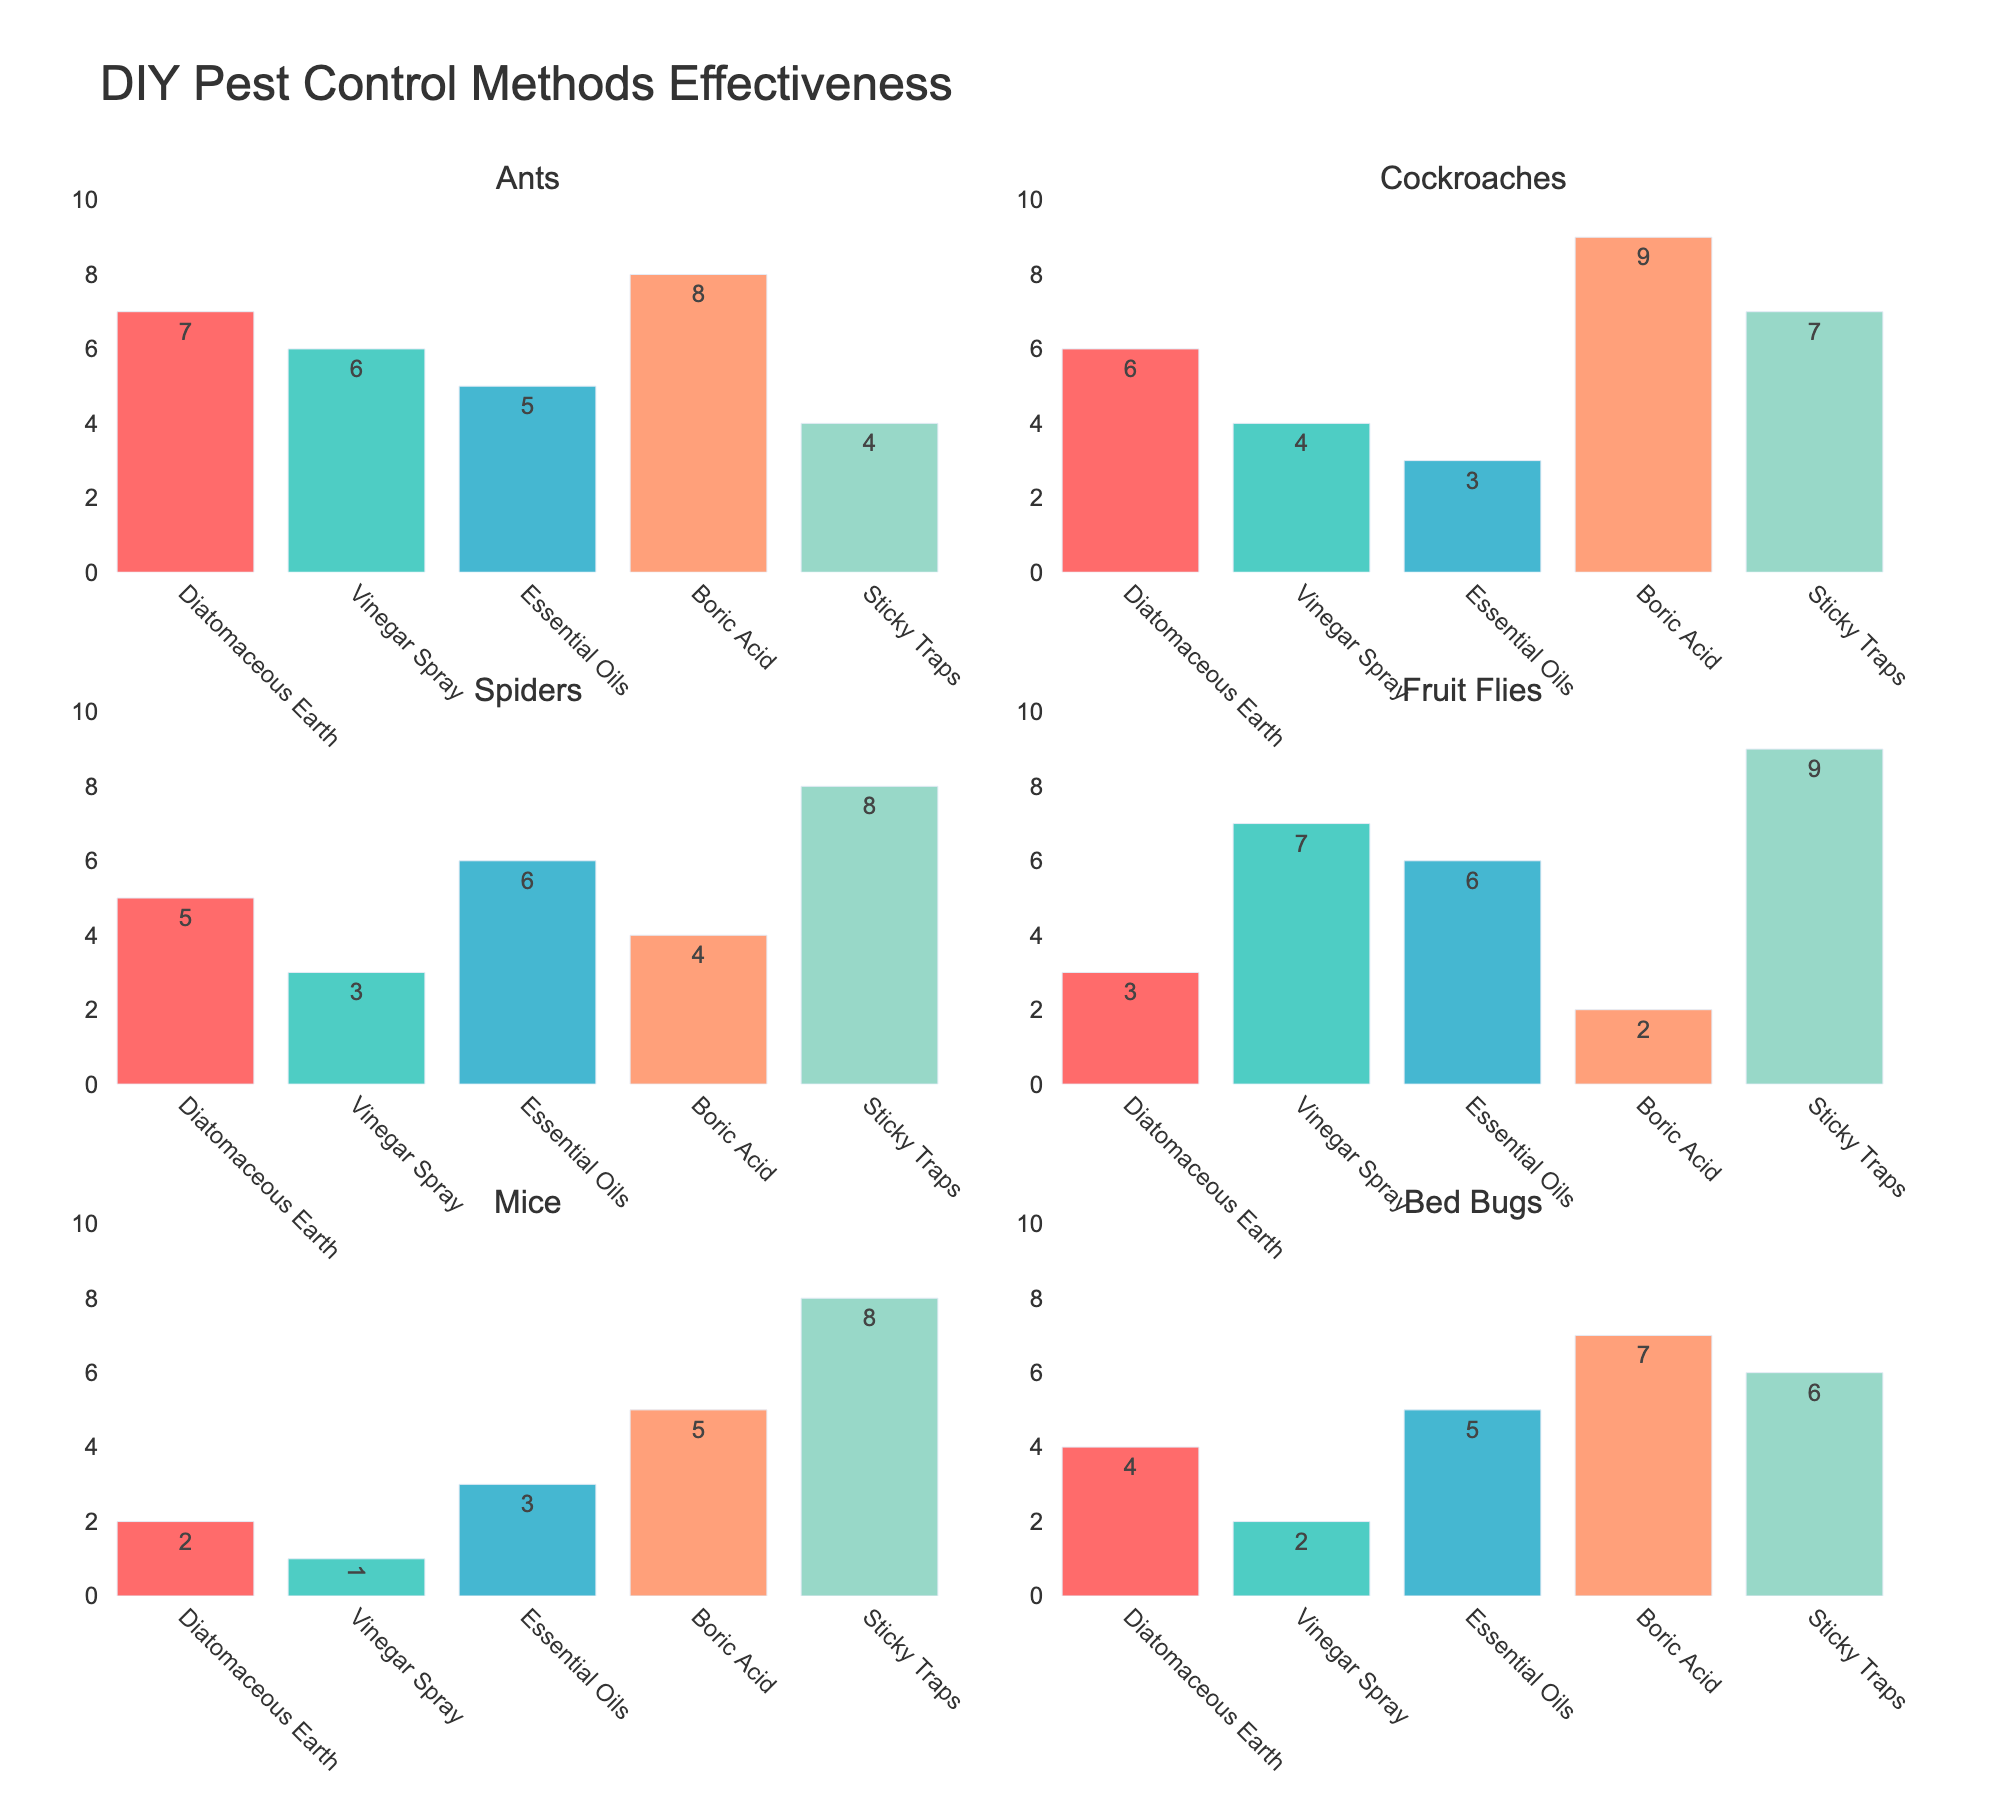What is the highest effectiveness rating for Diatomaceous Earth? Look at the bars corresponding to Diatomaceous Earth in all subplots and find the maximum value.
Answer: 7 For which pest is Vinegar Spray most effective? Find the highest bar for Vinegar Spray across all pests.
Answer: Fruit Flies Which method has the lowest effectiveness for Mice? Identify the lowest bar for Mice in the Mice subplot.
Answer: Vinegar Spray Compare the effectiveness of Boric Acid and Sticky Traps for Cockroaches. Which one is higher? Look at the bars for Boric Acid and Sticky Traps in the Cockroaches subplot and compare their heights.
Answer: Boric Acid What is the average effectiveness rating of Essential Oils across all pests? Sum the bars for Essential Oils in all subplots and divide by the number of pests (6). (5 + 3 + 6 + 6 + 3 + 5) / 6 = 4.67
Answer: 4.67 Which pest has the smallest variation in effectiveness ratings across all methods? Calculate the range (max - min) for each pest across all methods and identify the pest with the smallest range. Ants: 8-4 = 4, Cockroaches: 9-3 = 6, Spiders: 8-3 = 5, Fruit Flies: 9-2 = 7, Mice: 8-1 = 7, Bed Bugs: 7-2 = 5
Answer: Ants What is the combined effectiveness rating of Diatomaceous Earth and Boric Acid for Bed Bugs? Add the effectiveness ratings of Diatomaceous Earth and Boric Acid for Bed Bugs (4 + 7).
Answer: 11 